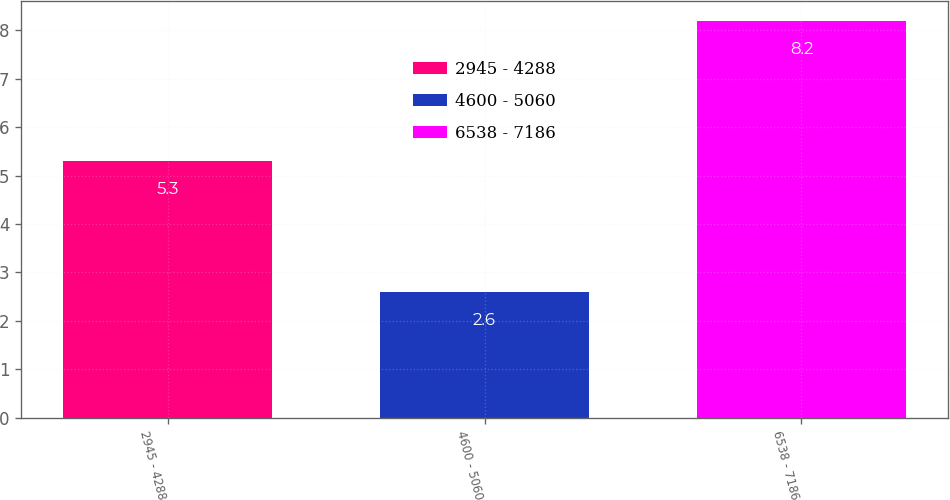<chart> <loc_0><loc_0><loc_500><loc_500><bar_chart><fcel>2945 - 4288<fcel>4600 - 5060<fcel>6538 - 7186<nl><fcel>5.3<fcel>2.6<fcel>8.2<nl></chart> 